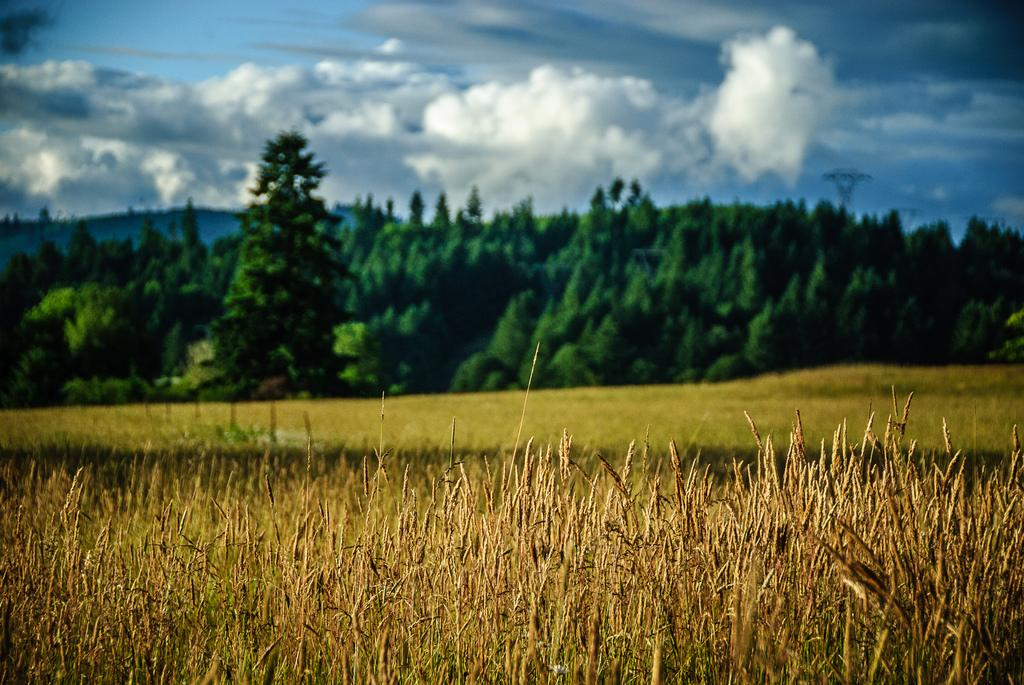What type of landscape is at the bottom of the image? There is a field at the bottom of the image. What can be seen in the middle of the image? There are trees in the middle of the image. What is visible in the background of the image? The sky is visible in the background of the image. How would you describe the sky in the image? The sky appears to be cloudy. Where can the stamp be found in the image? There is no stamp present in the image. What type of poison is visible in the image? There is no poison present in the image. 